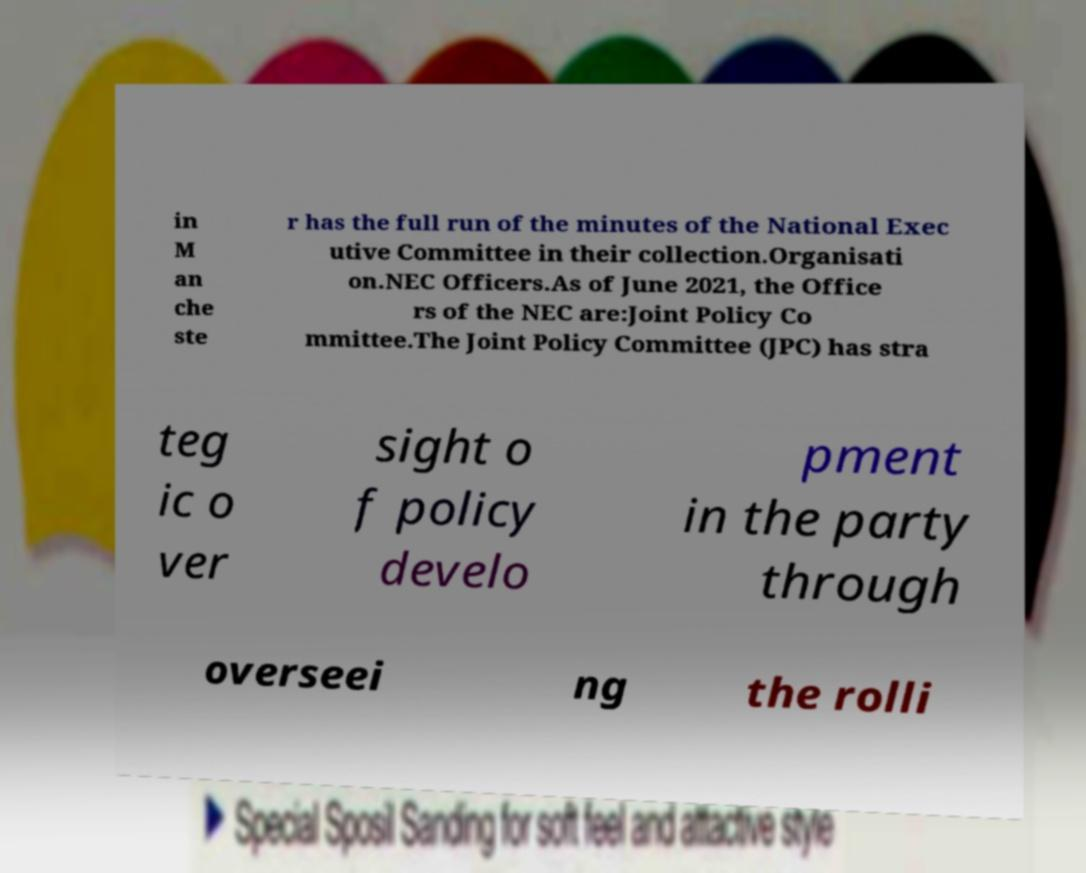Could you assist in decoding the text presented in this image and type it out clearly? in M an che ste r has the full run of the minutes of the National Exec utive Committee in their collection.Organisati on.NEC Officers.As of June 2021, the Office rs of the NEC are:Joint Policy Co mmittee.The Joint Policy Committee (JPC) has stra teg ic o ver sight o f policy develo pment in the party through overseei ng the rolli 